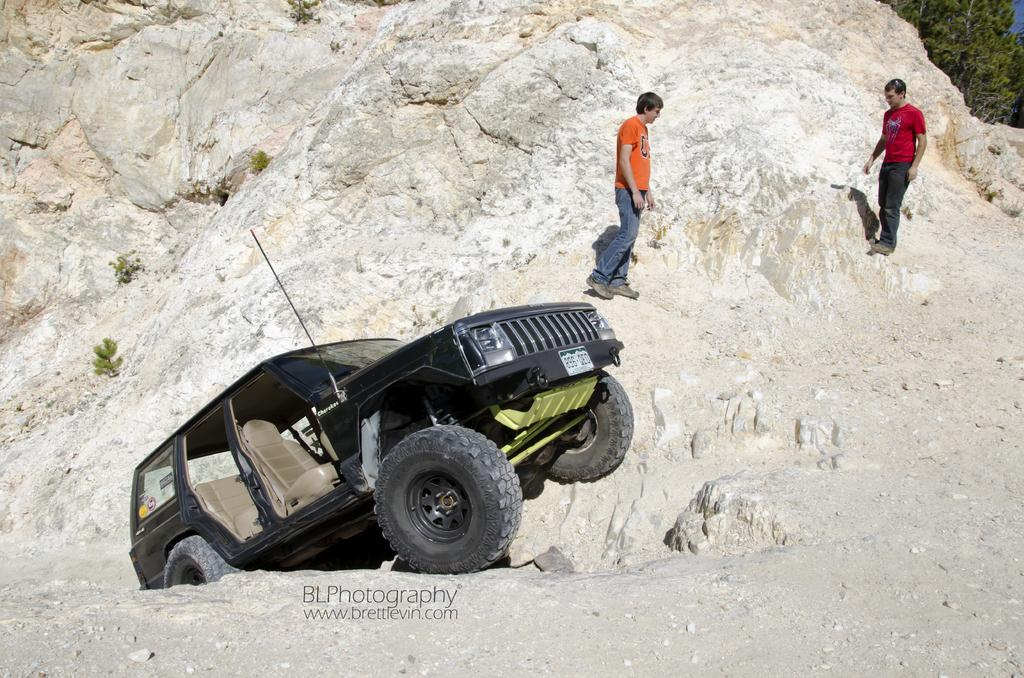What is the main subject of the image? The main subject of the image is a car. Can you describe the people in the image? There are two persons in the image, and they are standing on a rock. What type of organization is the band performing for in the image? There is no band or organization present in the image; it features a car and two people standing on a rock. 